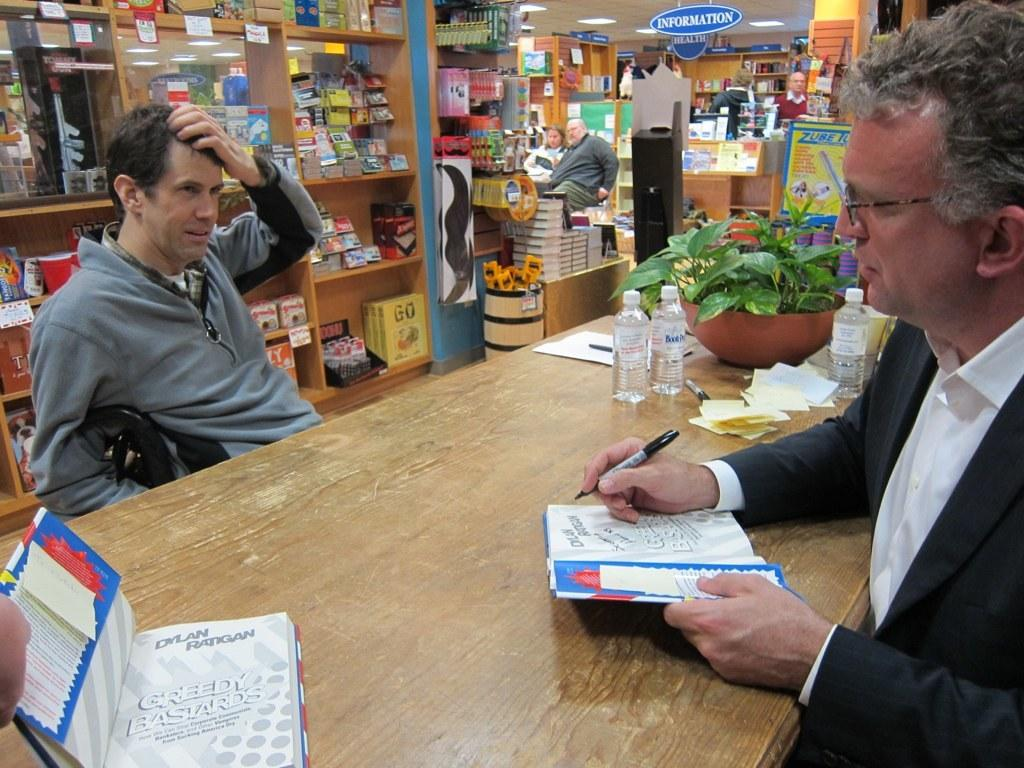<image>
Render a clear and concise summary of the photo. A man is standing near an information desk. 